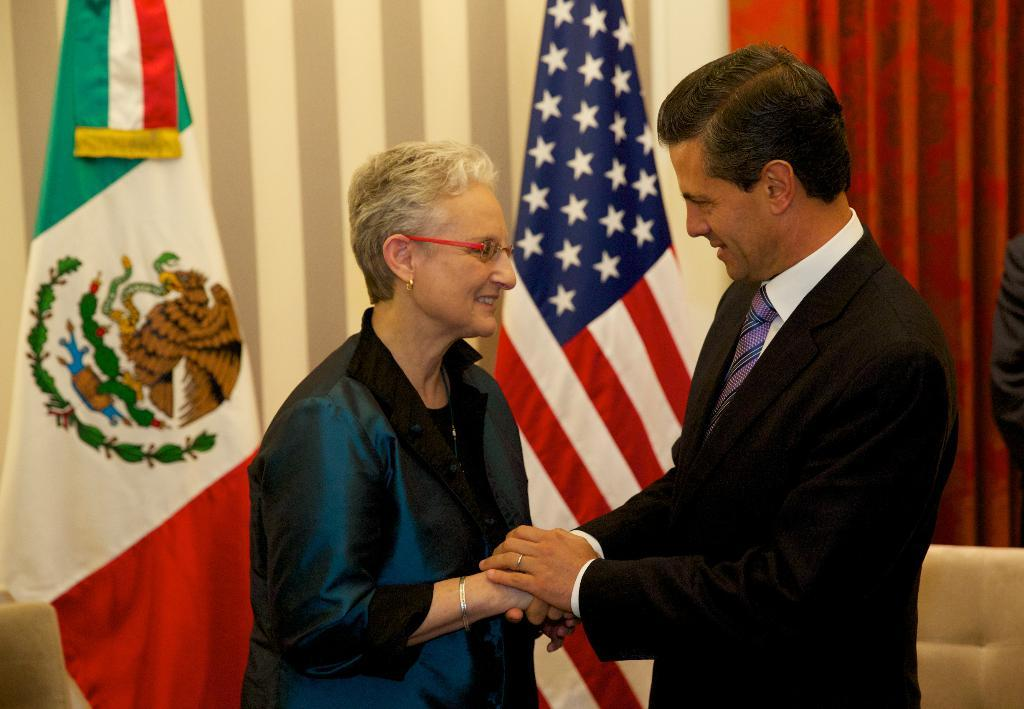Who is present in the image? There is a man in the image. What is the man doing in the image? The man is holding the woman's hands. What can be seen in the background of the image? There are two flags and a red color curtain in the background of the image. What type of leather material can be seen on the dock in the image? There is no dock or leather material present in the image. How many snakes are visible on the woman's hands in the image? There are no snakes visible on the woman's hands in the image. 